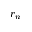<formula> <loc_0><loc_0><loc_500><loc_500>r _ { n }</formula> 